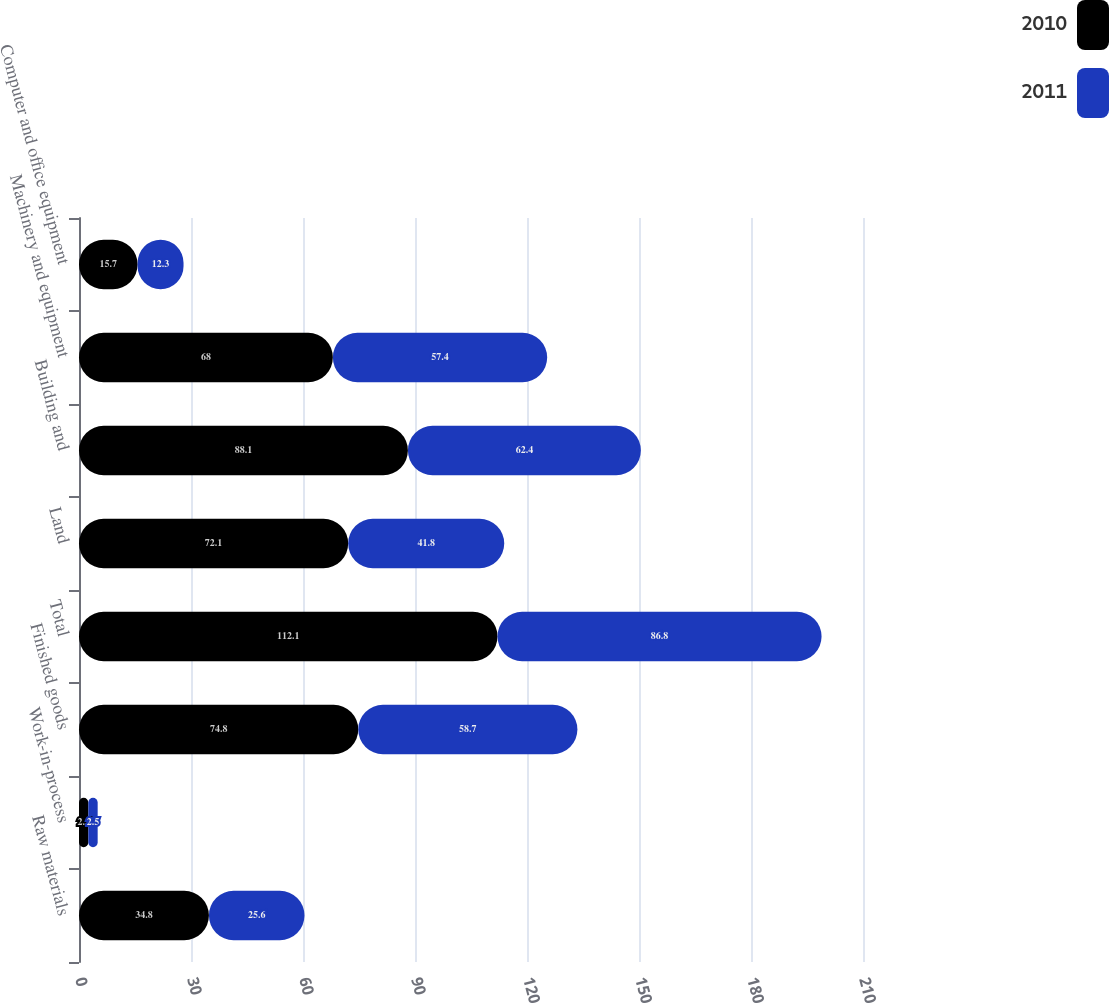Convert chart to OTSL. <chart><loc_0><loc_0><loc_500><loc_500><stacked_bar_chart><ecel><fcel>Raw materials<fcel>Work-in-process<fcel>Finished goods<fcel>Total<fcel>Land<fcel>Building and<fcel>Machinery and equipment<fcel>Computer and office equipment<nl><fcel>2010<fcel>34.8<fcel>2.5<fcel>74.8<fcel>112.1<fcel>72.1<fcel>88.1<fcel>68<fcel>15.7<nl><fcel>2011<fcel>25.6<fcel>2.5<fcel>58.7<fcel>86.8<fcel>41.8<fcel>62.4<fcel>57.4<fcel>12.3<nl></chart> 